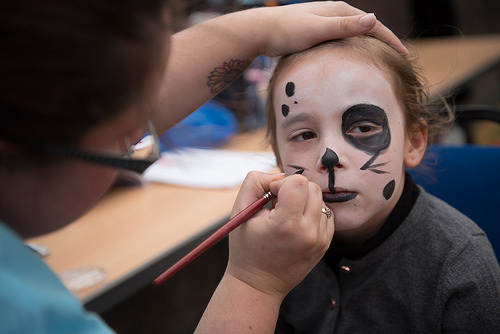<image>
Can you confirm if the face painter is on the girl? Yes. Looking at the image, I can see the face painter is positioned on top of the girl, with the girl providing support. 